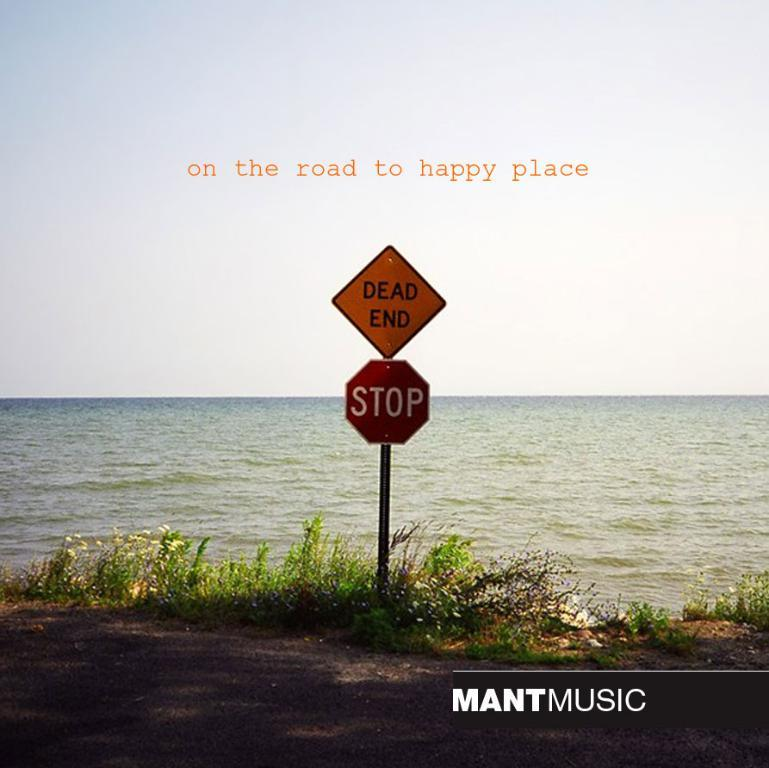<image>
Present a compact description of the photo's key features. A yellow dead end sign is directly above a stop sign. 